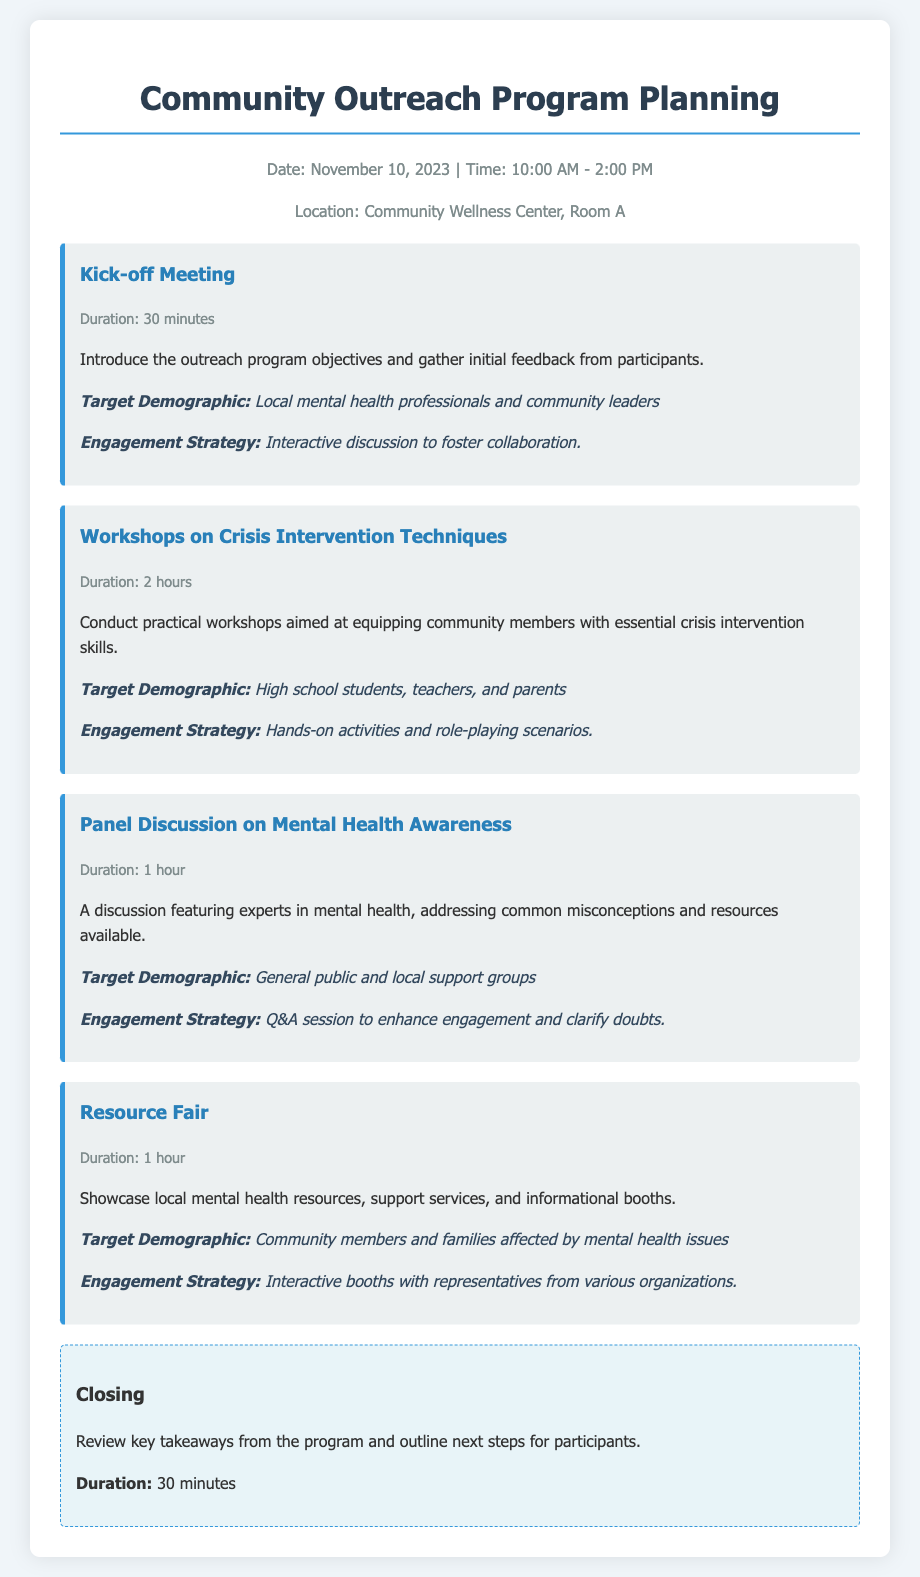What is the date of the program? The date of the program is specified in the header info section of the document.
Answer: November 10, 2023 How long is the Kick-off Meeting? The duration is mentioned in the event details for the Kick-off Meeting.
Answer: 30 minutes Who is the target demographic for the Resource Fair? This information is provided in the event description under the Resource Fair.
Answer: Community members and families affected by mental health issues What is one of the engagement strategies for the workshops? This detail is noted in the description of the Workshops on Crisis Intervention Techniques.
Answer: Hands-on activities and role-playing scenarios What session focuses on mental health awareness? The document lists various events, and this specific session is titled in the event sections.
Answer: Panel Discussion on Mental Health Awareness How long will the Resource Fair last? The duration for the Resource Fair is listed in the event info section.
Answer: 1 hour What is the main purpose of the Kick-off Meeting? The purpose is outlined in the description of the event.
Answer: Introduce the outreach program objectives and gather initial feedback from participants What will happen during the closing session? The closing section details the activities planned for this part of the agenda.
Answer: Review key takeaways from the program and outline next steps for participants 